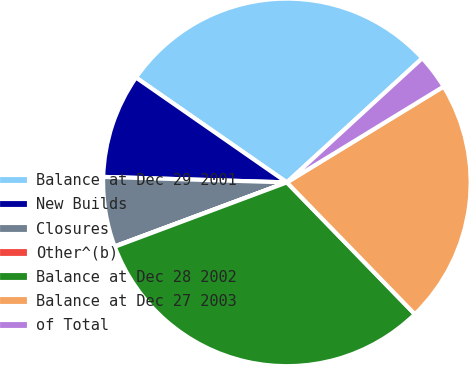Convert chart to OTSL. <chart><loc_0><loc_0><loc_500><loc_500><pie_chart><fcel>Balance at Dec 29 2001<fcel>New Builds<fcel>Closures<fcel>Other^(b)<fcel>Balance at Dec 28 2002<fcel>Balance at Dec 27 2003<fcel>of Total<nl><fcel>28.52%<fcel>9.19%<fcel>6.14%<fcel>0.03%<fcel>31.57%<fcel>21.47%<fcel>3.08%<nl></chart> 